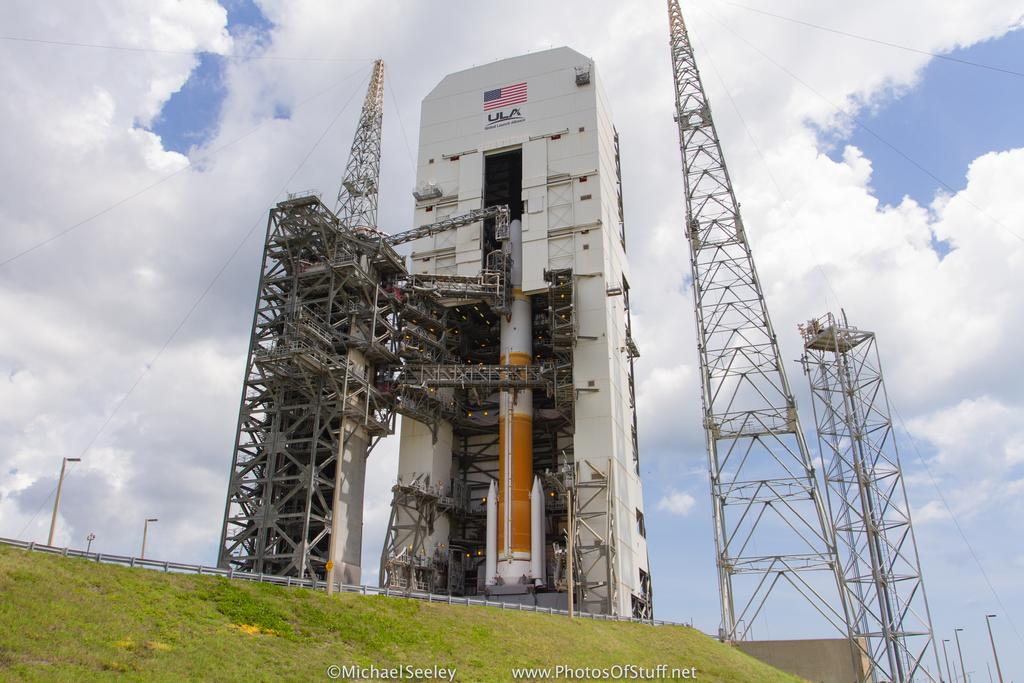<image>
Write a terse but informative summary of the picture. Under the American Flag it says United Launch Alliance. 